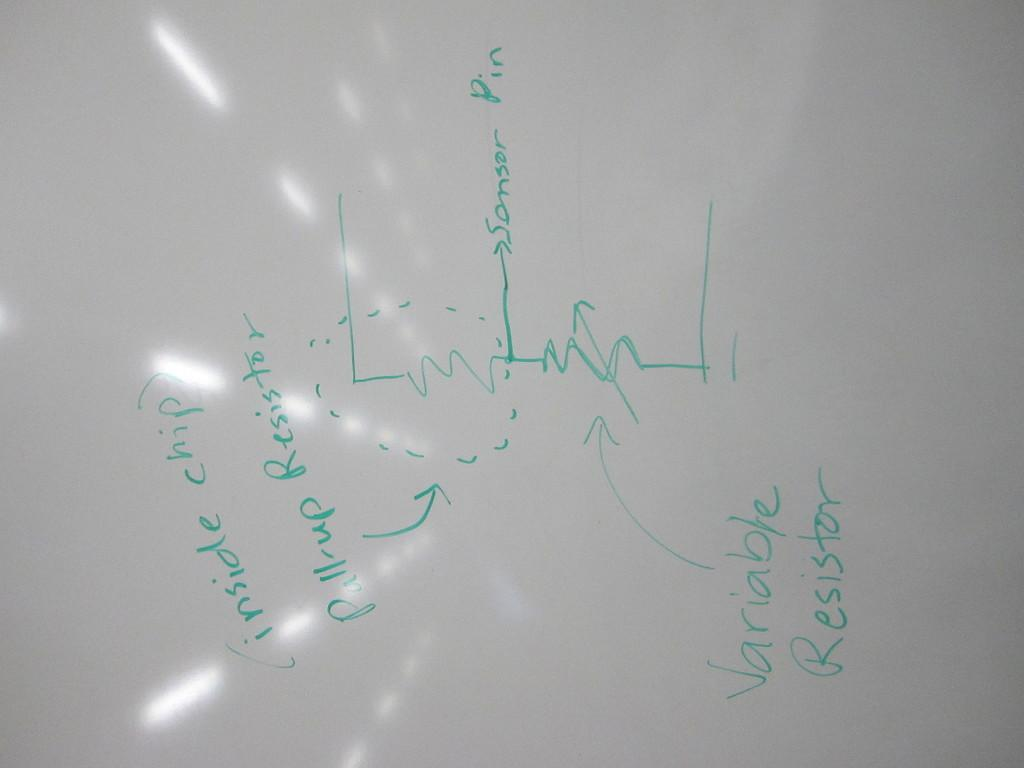<image>
Share a concise interpretation of the image provided. a whiteboard with the words 'variable resistor' written on it 